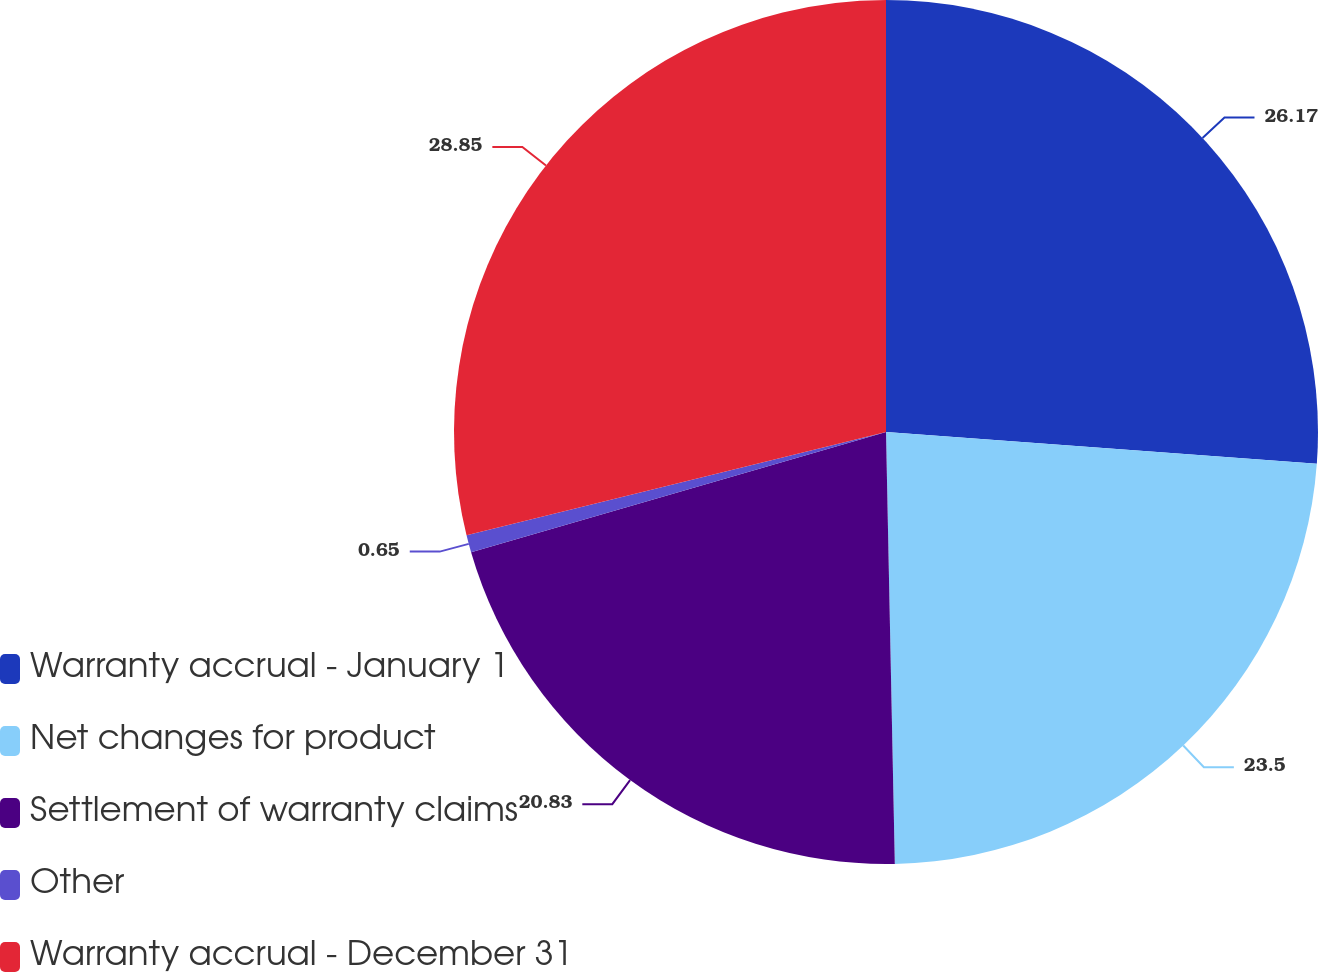Convert chart to OTSL. <chart><loc_0><loc_0><loc_500><loc_500><pie_chart><fcel>Warranty accrual - January 1<fcel>Net changes for product<fcel>Settlement of warranty claims<fcel>Other<fcel>Warranty accrual - December 31<nl><fcel>26.17%<fcel>23.5%<fcel>20.83%<fcel>0.65%<fcel>28.84%<nl></chart> 